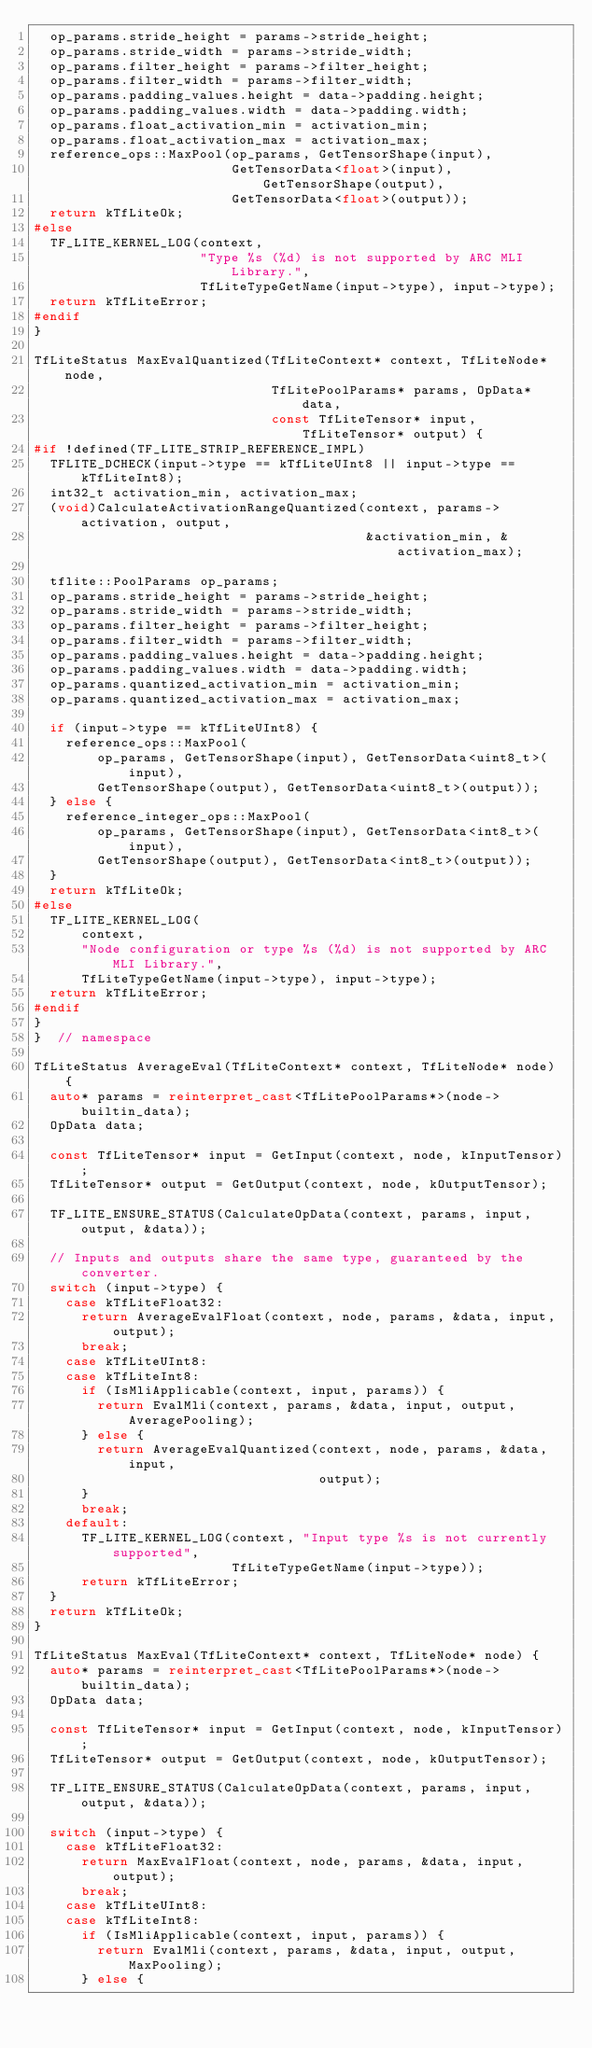Convert code to text. <code><loc_0><loc_0><loc_500><loc_500><_C++_>  op_params.stride_height = params->stride_height;
  op_params.stride_width = params->stride_width;
  op_params.filter_height = params->filter_height;
  op_params.filter_width = params->filter_width;
  op_params.padding_values.height = data->padding.height;
  op_params.padding_values.width = data->padding.width;
  op_params.float_activation_min = activation_min;
  op_params.float_activation_max = activation_max;
  reference_ops::MaxPool(op_params, GetTensorShape(input),
                         GetTensorData<float>(input), GetTensorShape(output),
                         GetTensorData<float>(output));
  return kTfLiteOk;
#else
  TF_LITE_KERNEL_LOG(context,
                     "Type %s (%d) is not supported by ARC MLI Library.",
                     TfLiteTypeGetName(input->type), input->type);
  return kTfLiteError;
#endif
}

TfLiteStatus MaxEvalQuantized(TfLiteContext* context, TfLiteNode* node,
                              TfLitePoolParams* params, OpData* data,
                              const TfLiteTensor* input, TfLiteTensor* output) {
#if !defined(TF_LITE_STRIP_REFERENCE_IMPL)
  TFLITE_DCHECK(input->type == kTfLiteUInt8 || input->type == kTfLiteInt8);
  int32_t activation_min, activation_max;
  (void)CalculateActivationRangeQuantized(context, params->activation, output,
                                          &activation_min, &activation_max);

  tflite::PoolParams op_params;
  op_params.stride_height = params->stride_height;
  op_params.stride_width = params->stride_width;
  op_params.filter_height = params->filter_height;
  op_params.filter_width = params->filter_width;
  op_params.padding_values.height = data->padding.height;
  op_params.padding_values.width = data->padding.width;
  op_params.quantized_activation_min = activation_min;
  op_params.quantized_activation_max = activation_max;

  if (input->type == kTfLiteUInt8) {
    reference_ops::MaxPool(
        op_params, GetTensorShape(input), GetTensorData<uint8_t>(input),
        GetTensorShape(output), GetTensorData<uint8_t>(output));
  } else {
    reference_integer_ops::MaxPool(
        op_params, GetTensorShape(input), GetTensorData<int8_t>(input),
        GetTensorShape(output), GetTensorData<int8_t>(output));
  }
  return kTfLiteOk;
#else
  TF_LITE_KERNEL_LOG(
      context,
      "Node configuration or type %s (%d) is not supported by ARC MLI Library.",
      TfLiteTypeGetName(input->type), input->type);
  return kTfLiteError;
#endif
}
}  // namespace

TfLiteStatus AverageEval(TfLiteContext* context, TfLiteNode* node) {
  auto* params = reinterpret_cast<TfLitePoolParams*>(node->builtin_data);
  OpData data;

  const TfLiteTensor* input = GetInput(context, node, kInputTensor);
  TfLiteTensor* output = GetOutput(context, node, kOutputTensor);

  TF_LITE_ENSURE_STATUS(CalculateOpData(context, params, input, output, &data));

  // Inputs and outputs share the same type, guaranteed by the converter.
  switch (input->type) {
    case kTfLiteFloat32:
      return AverageEvalFloat(context, node, params, &data, input, output);
      break;
    case kTfLiteUInt8:
    case kTfLiteInt8:
      if (IsMliApplicable(context, input, params)) {
        return EvalMli(context, params, &data, input, output, AveragePooling);
      } else {
        return AverageEvalQuantized(context, node, params, &data, input,
                                    output);
      }
      break;
    default:
      TF_LITE_KERNEL_LOG(context, "Input type %s is not currently supported",
                         TfLiteTypeGetName(input->type));
      return kTfLiteError;
  }
  return kTfLiteOk;
}

TfLiteStatus MaxEval(TfLiteContext* context, TfLiteNode* node) {
  auto* params = reinterpret_cast<TfLitePoolParams*>(node->builtin_data);
  OpData data;

  const TfLiteTensor* input = GetInput(context, node, kInputTensor);
  TfLiteTensor* output = GetOutput(context, node, kOutputTensor);

  TF_LITE_ENSURE_STATUS(CalculateOpData(context, params, input, output, &data));

  switch (input->type) {
    case kTfLiteFloat32:
      return MaxEvalFloat(context, node, params, &data, input, output);
      break;
    case kTfLiteUInt8:
    case kTfLiteInt8:
      if (IsMliApplicable(context, input, params)) {
        return EvalMli(context, params, &data, input, output, MaxPooling);
      } else {</code> 